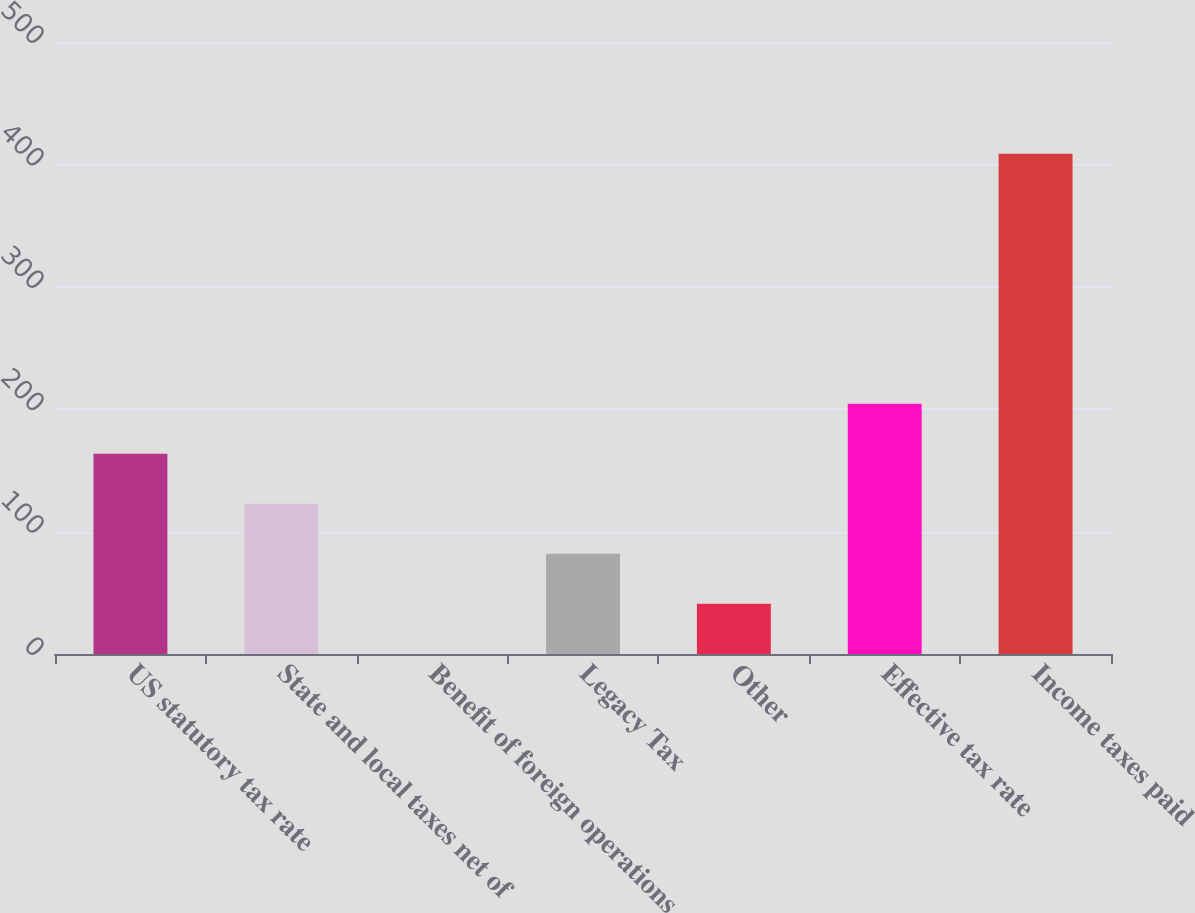Convert chart. <chart><loc_0><loc_0><loc_500><loc_500><bar_chart><fcel>US statutory tax rate<fcel>State and local taxes net of<fcel>Benefit of foreign operations<fcel>Legacy Tax<fcel>Other<fcel>Effective tax rate<fcel>Income taxes paid<nl><fcel>163.54<fcel>122.68<fcel>0.1<fcel>81.82<fcel>40.96<fcel>204.4<fcel>408.7<nl></chart> 